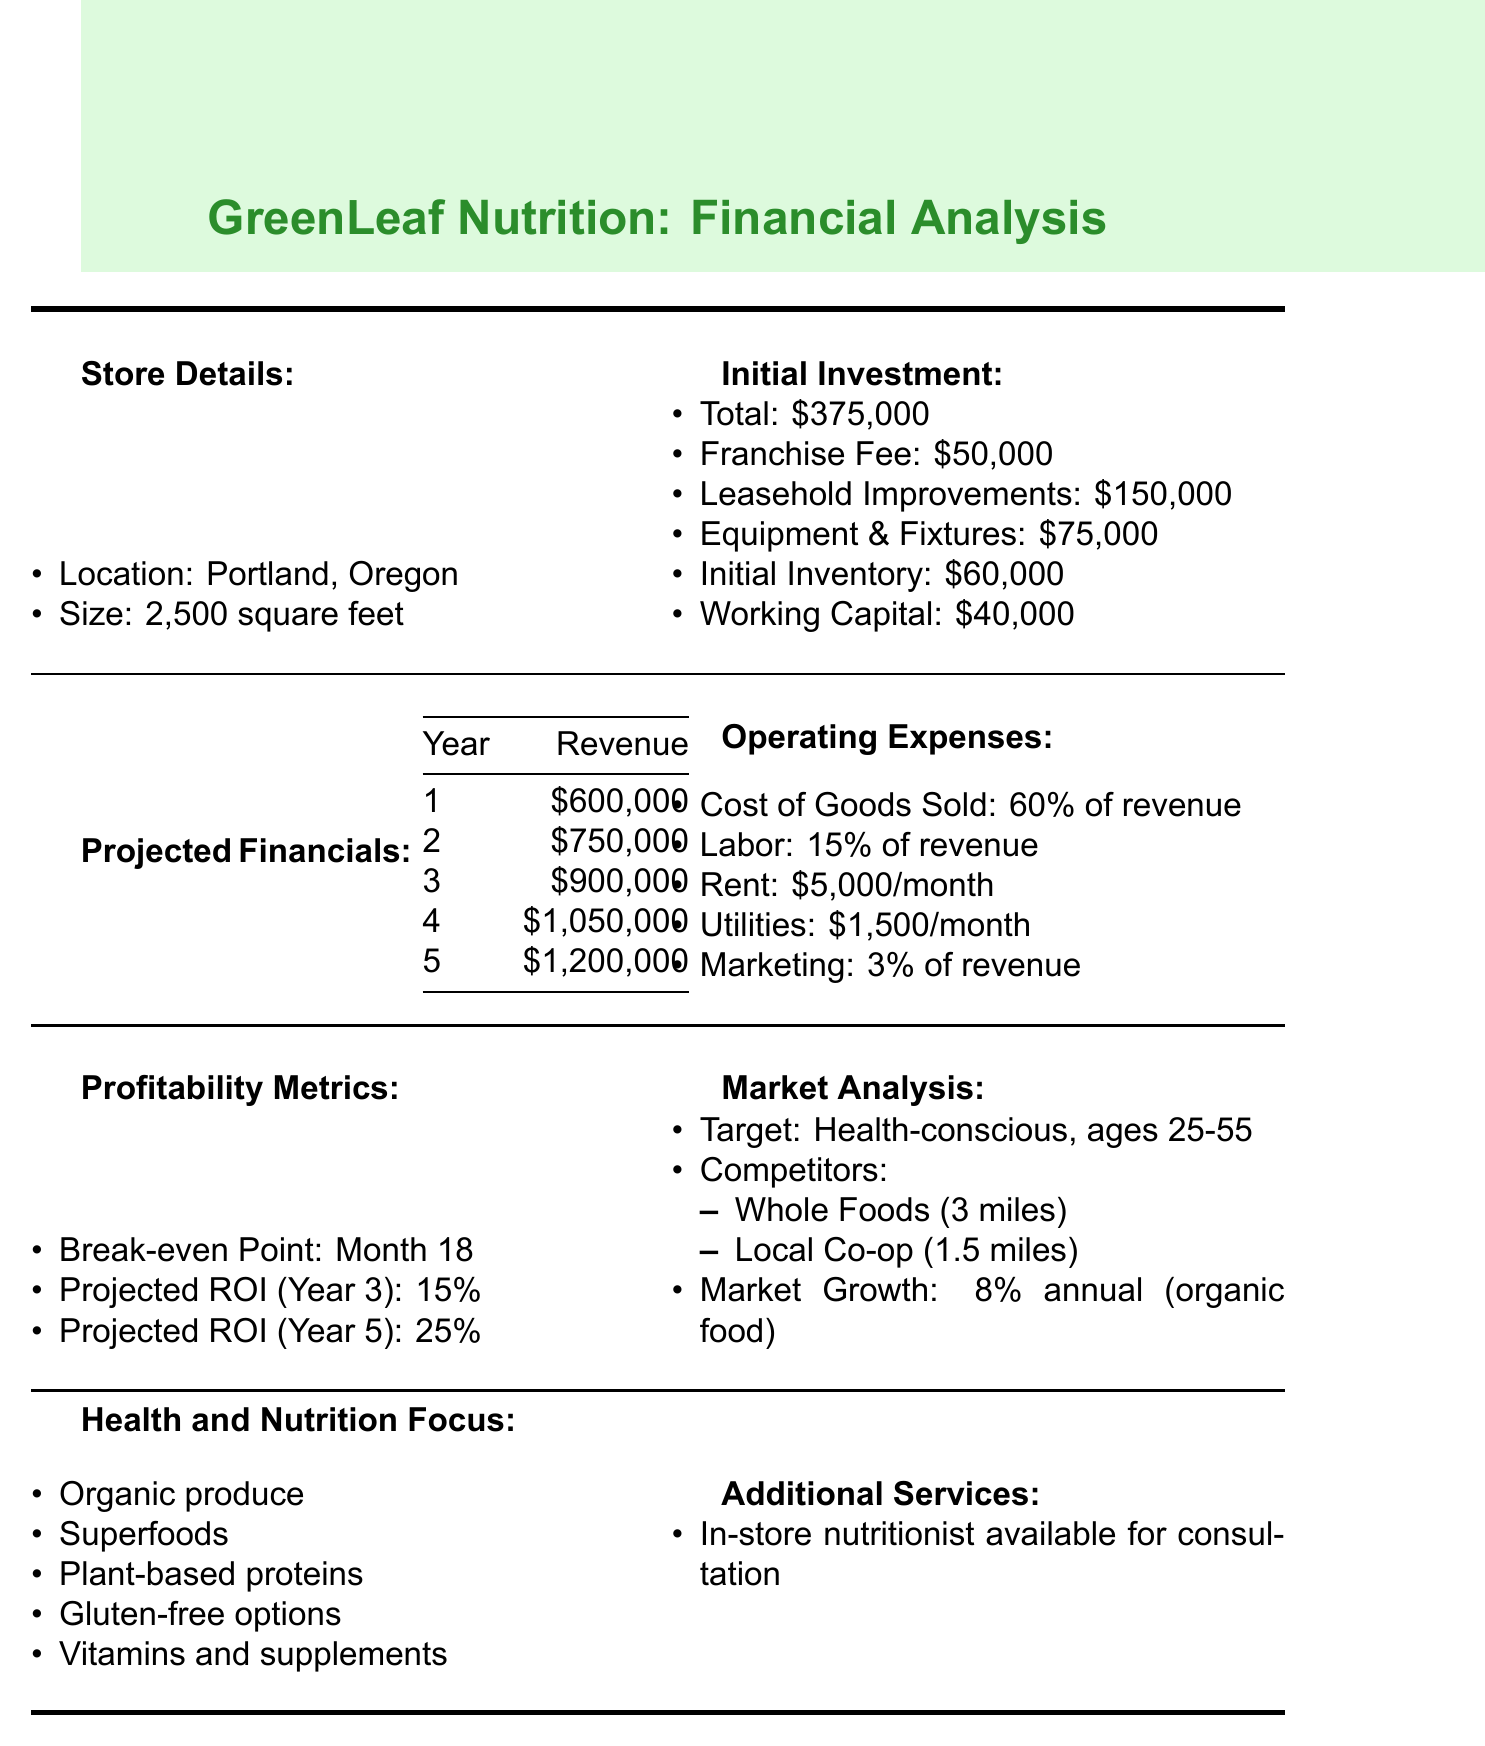What is the franchise name? The franchise name is clearly stated in the document under the store details.
Answer: GreenLeaf Nutrition What is the total initial investment? The total initial investment is summarized in the initial investment section of the document.
Answer: $375,000 What is the projected revenue in year 3? The projected financials section provides a breakdown of the yearly revenue over five years.
Answer: $900,000 What is the monthly rent expense? The rent expense is specified as a monthly amount in the operating expenses section.
Answer: $5,000 per month When is the break-even point? The break-even point is outlined in the profitability metrics section of the document.
Answer: Month 18 What percentage of revenue is allocated for marketing? The percentage allocation for marketing is detailed in the operating expenses section.
Answer: 3% of revenue Who is the target demographic for the store? The target demographic is mentioned in the market analysis part of the document.
Answer: Health-conscious consumers aged 25-55 What is the projected ROI for year 5? The projected ROI is presented in the profitability metrics section and pertains to year 5.
Answer: 25% 